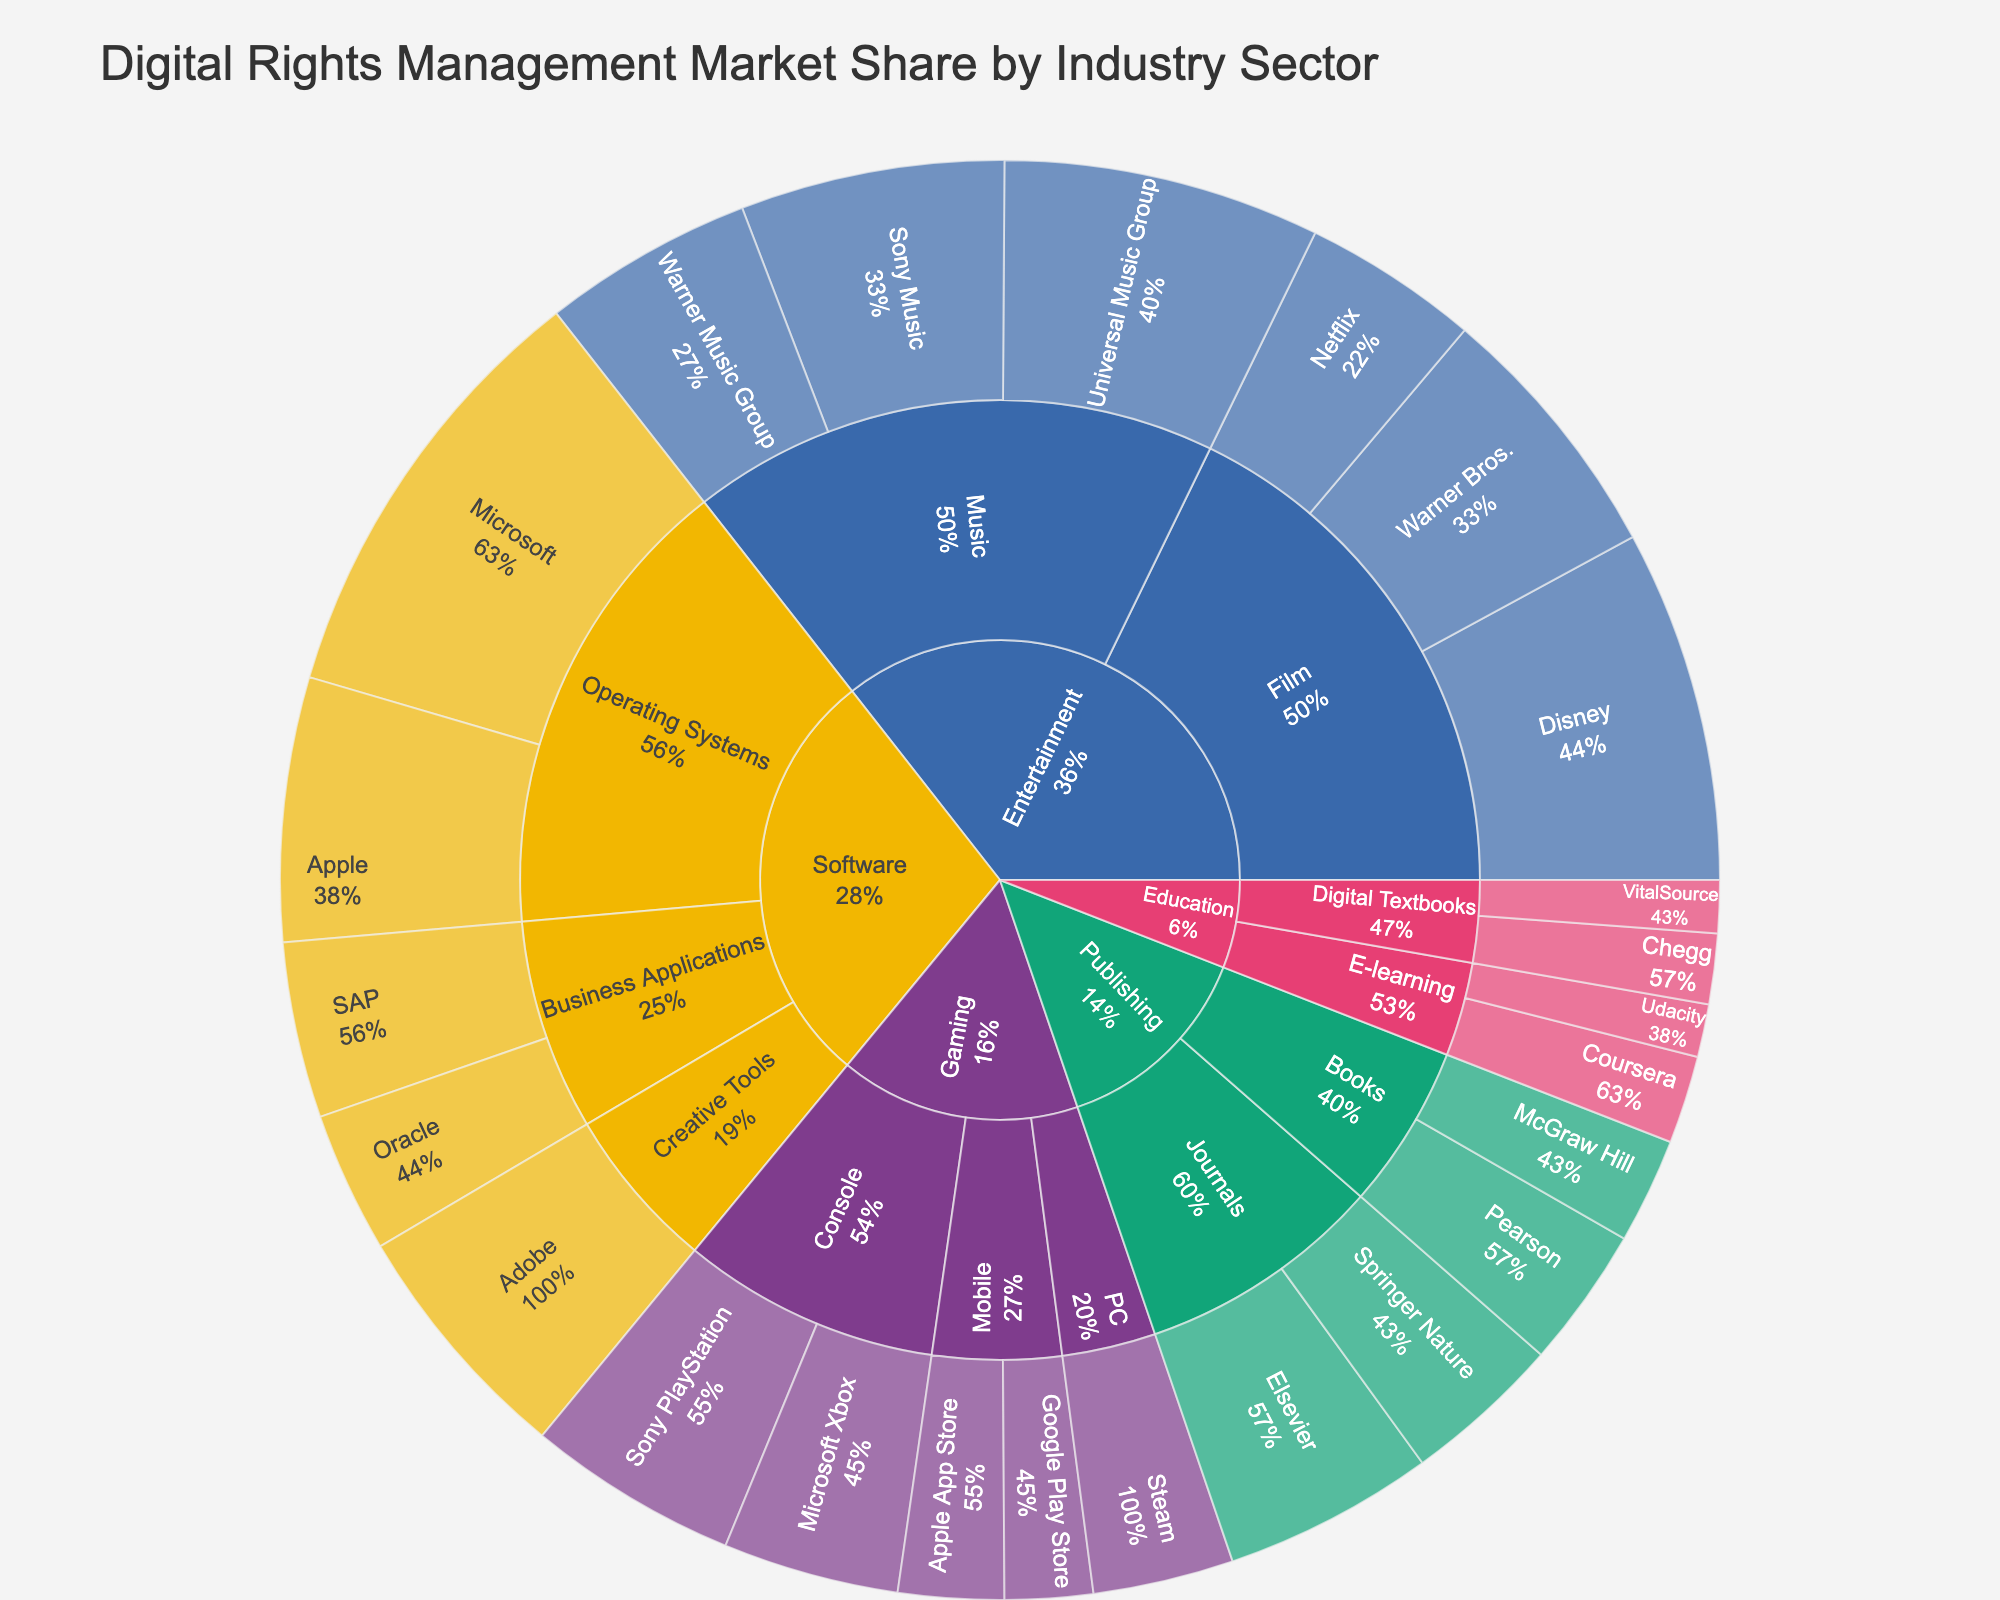What's the title of the Sunburst Plot? The title of the Sunburst Plot is positioned at the top of the figure and is typically displayed in larger font size with bold text. The title summarizes what the plot illustrates.
Answer: Digital Rights Management Market Share by Industry Sector Which company holds the largest market share in the Software sector? To find the company with the largest market share in the Software sector, look within the Software section of the Sunburst Plot. Identify the company with the largest segment in that section.
Answer: Microsoft What is the combined market share of the Apple companies in the plot? First, identify all the segments associated with Apple (Apple in Software and Google Play Store in Gaming for the mobile). Summing their market shares: 15% (Operating Systems) + 5% (Mobile in Gaming).
Answer: 20% Which sector in the Entertainment industry has the highest total market share? Compare the total market shares of Music and Film within the Entertainment sector by looking at the size of each sector's portion. The sector with the bigger section has the higher market share.
Answer: Film Compare the market share of Universal Music Group and Warner Music Group. Which one is larger and by how much? Look at the market shares for Universal Music Group and Warner Music Group in the Music sector of the Entertainment industry. Subtract Warner Music Group's share from Universal Music Group's share.
Answer: Universal Music Group by 6% What's the total market share of the Education industry? Aggregate the market shares of all the companies within the Education sector: Coursera (5), Udacity (3), Chegg (4), and VitalSource (3). Then sum these values: 5 + 3 + 4 + 3.
Answer: 15% Which sector has the smallest individual market share and what is the value? Examine each segment in the Sunburst Plot to identify the one with the smallest market share.
Answer: E-learning in Education by Udacity and Digital Textbooks in Education by VitalSource with 3% each Which industry has the largest market share in the plot? Search for the industry with the largest cumulative market share by visually estimating the relative size of each industry's section in the Sunburst Plot.
Answer: Entertainment What's the difference in market share between the largest and smallest companies within the Gaming industry? Identify the largest (Sony PlayStation with 12%) and the smallest (Google Play Store with 5%) companies in the Gaming sector. Subtract the market share of the smallest from the largest.
Answer: 7% How do the market shares of Pearson and Elsevier in the Publishing sector compare? Locate the market shares for Pearson and Elsevier in the Publishing sector. Compare their market shares to determine the larger one and quantify the difference.
Answer: Elsevier is 4% larger than Pearson 